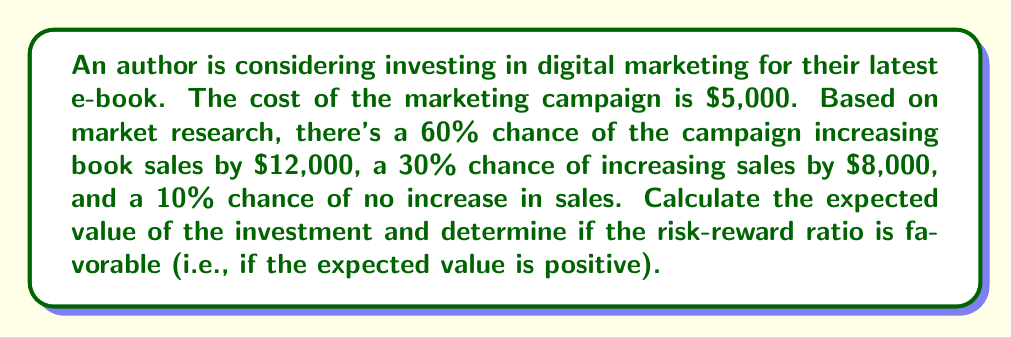Can you answer this question? To solve this problem, we need to calculate the expected value of the investment using the given probabilities and potential outcomes. Then, we'll subtract the cost of the marketing campaign to determine if the investment is favorable.

1. Calculate the expected value of the sales increase:
   $$E(\text{sales increase}) = 0.60 \times \$12,000 + 0.30 \times \$8,000 + 0.10 \times \$0$$
   $$E(\text{sales increase}) = \$7,200 + \$2,400 + \$0 = \$9,600$$

2. Calculate the net expected value by subtracting the cost of the marketing campaign:
   $$E(\text{net value}) = E(\text{sales increase}) - \text{cost}$$
   $$E(\text{net value}) = \$9,600 - \$5,000 = \$4,600$$

3. Determine if the risk-reward ratio is favorable:
   Since the expected net value is positive ($4,600 > 0), the risk-reward ratio is favorable.

To calculate the risk-reward ratio, we can use:
   $$\text{Risk-Reward Ratio} = \frac{\text{Potential Loss}}{\text{Expected Gain}} = \frac{\$5,000}{\$4,600} \approx 1.09$$

This means that for every $1.09 risked, the author can expect to gain $1 in return, which is a favorable ratio.
Answer: The expected value of the investment is $4,600, and the risk-reward ratio is favorable since the expected value is positive. 